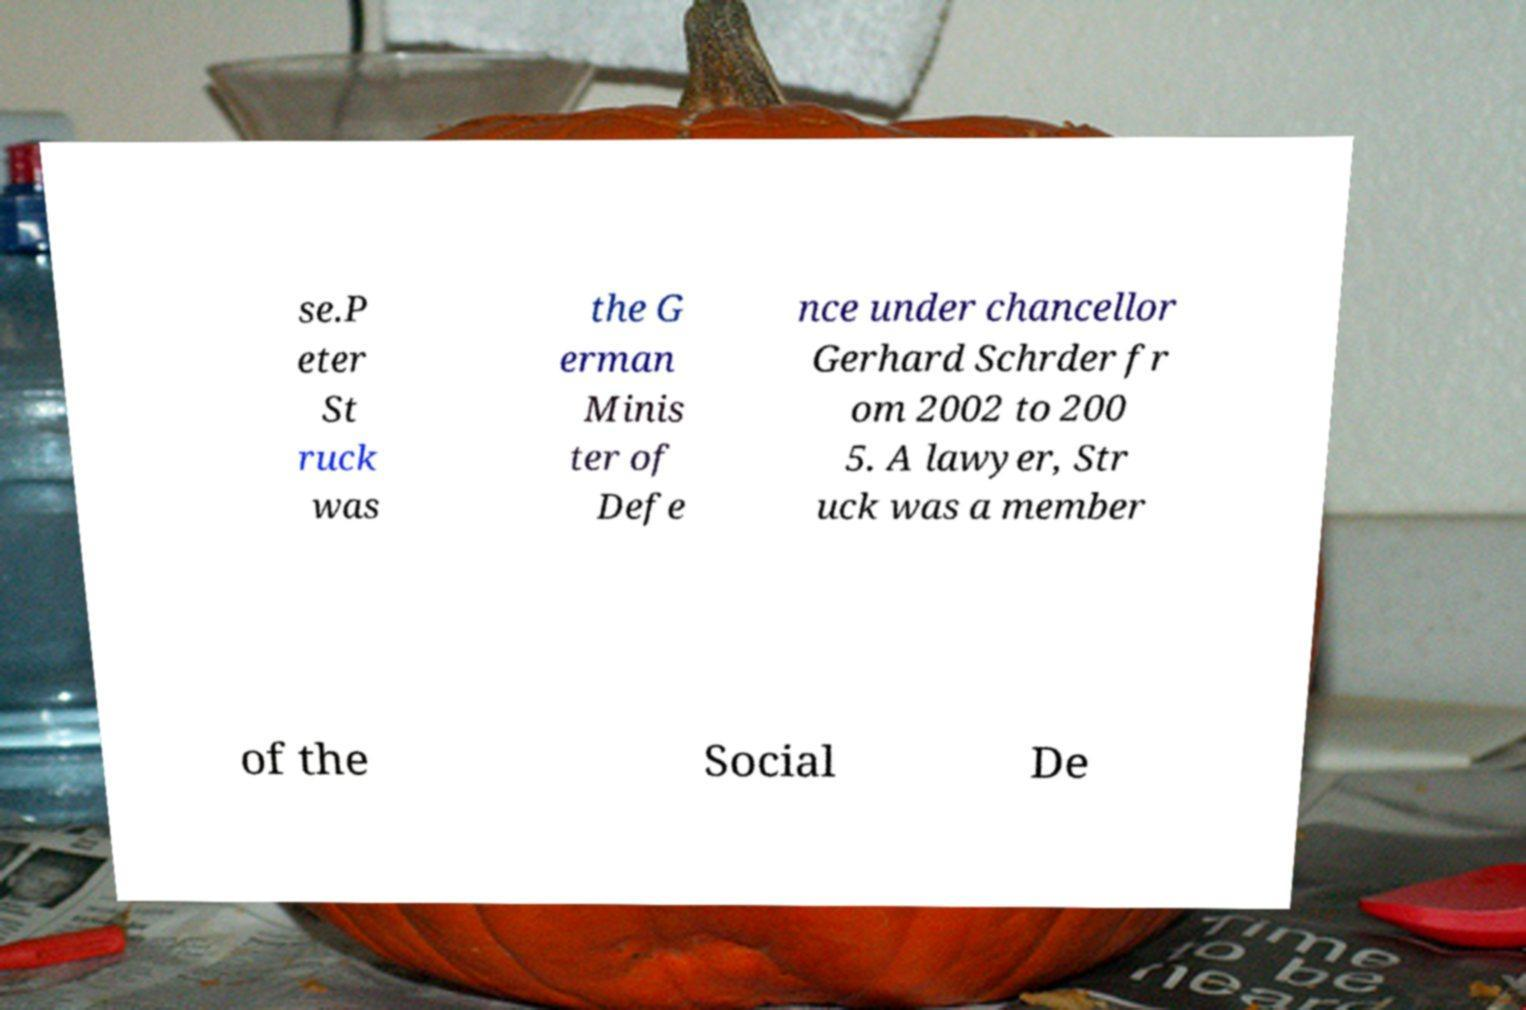What messages or text are displayed in this image? I need them in a readable, typed format. se.P eter St ruck was the G erman Minis ter of Defe nce under chancellor Gerhard Schrder fr om 2002 to 200 5. A lawyer, Str uck was a member of the Social De 